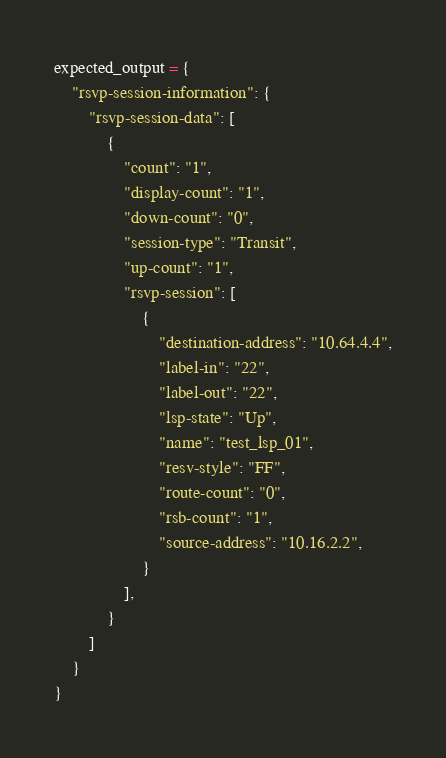<code> <loc_0><loc_0><loc_500><loc_500><_Python_>expected_output = {
    "rsvp-session-information": {
        "rsvp-session-data": [
            {
                "count": "1",
                "display-count": "1",
                "down-count": "0",
                "session-type": "Transit",
                "up-count": "1",
                "rsvp-session": [
                    {
                        "destination-address": "10.64.4.4",
                        "label-in": "22",
                        "label-out": "22",
                        "lsp-state": "Up",
                        "name": "test_lsp_01",
                        "resv-style": "FF",
                        "route-count": "0",
                        "rsb-count": "1",
                        "source-address": "10.16.2.2",
                    }
                ],
            }
        ]
    }
}
</code> 